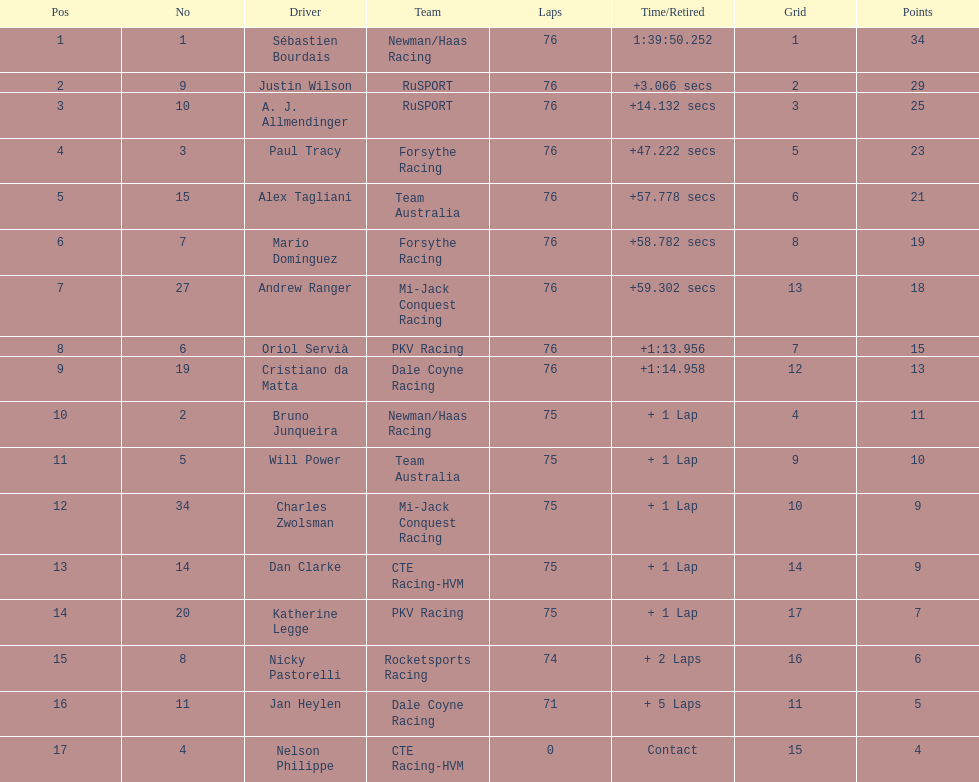Which canadian driver finished first: alex tagliani or paul tracy? Paul Tracy. 